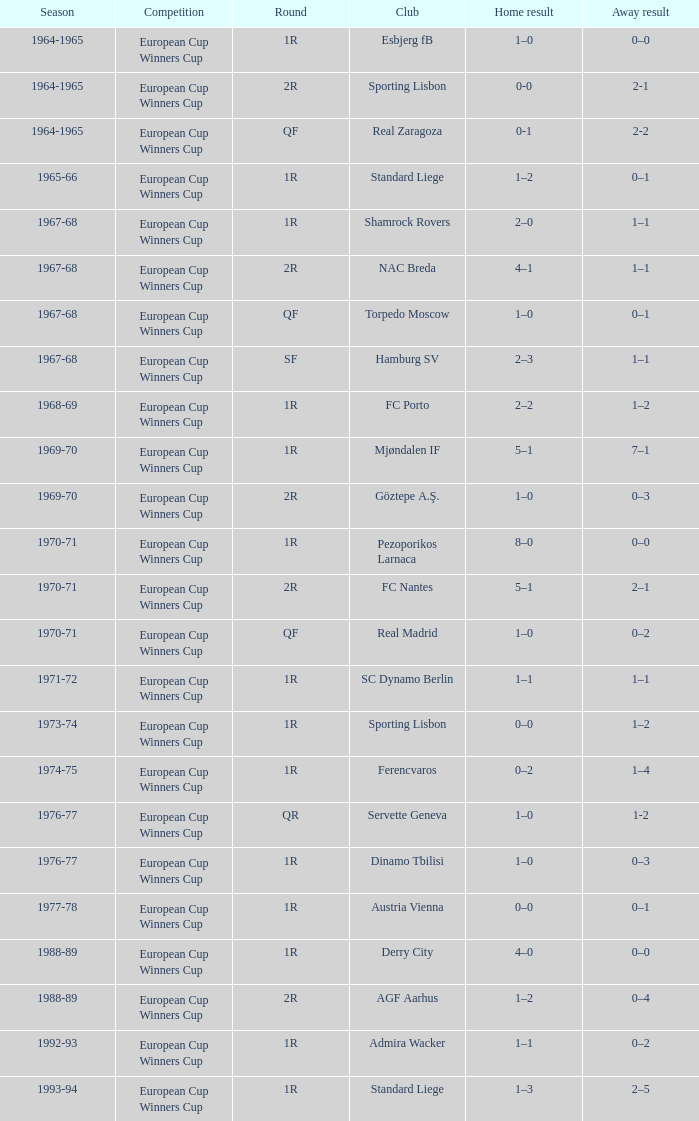Round of 1r, and an away result of 7–1 is what season? 1969-70. 